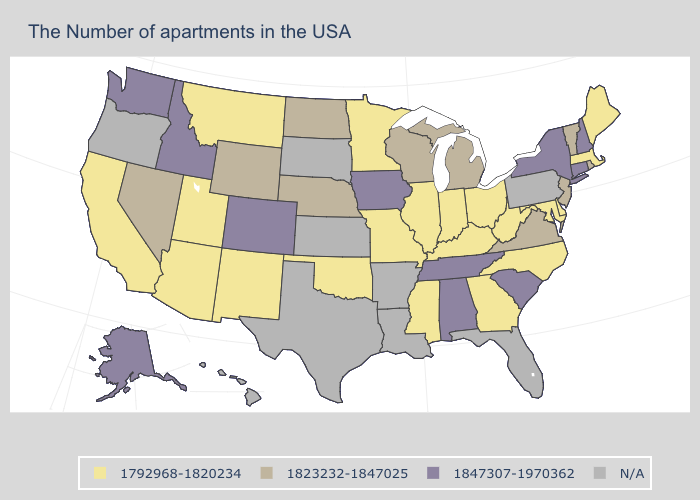What is the lowest value in the West?
Give a very brief answer. 1792968-1820234. Which states have the lowest value in the USA?
Write a very short answer. Maine, Massachusetts, Delaware, Maryland, North Carolina, West Virginia, Ohio, Georgia, Kentucky, Indiana, Illinois, Mississippi, Missouri, Minnesota, Oklahoma, New Mexico, Utah, Montana, Arizona, California. What is the value of Wisconsin?
Quick response, please. 1823232-1847025. Name the states that have a value in the range 1823232-1847025?
Quick response, please. Rhode Island, Vermont, New Jersey, Virginia, Michigan, Wisconsin, Nebraska, North Dakota, Wyoming, Nevada. What is the lowest value in the Northeast?
Answer briefly. 1792968-1820234. What is the value of Alabama?
Short answer required. 1847307-1970362. Among the states that border Nevada , which have the lowest value?
Answer briefly. Utah, Arizona, California. Name the states that have a value in the range 1823232-1847025?
Short answer required. Rhode Island, Vermont, New Jersey, Virginia, Michigan, Wisconsin, Nebraska, North Dakota, Wyoming, Nevada. Which states hav the highest value in the Northeast?
Give a very brief answer. New Hampshire, Connecticut, New York. What is the highest value in states that border Georgia?
Answer briefly. 1847307-1970362. Does the map have missing data?
Keep it brief. Yes. Does the first symbol in the legend represent the smallest category?
Write a very short answer. Yes. Name the states that have a value in the range N/A?
Give a very brief answer. Pennsylvania, Florida, Louisiana, Arkansas, Kansas, Texas, South Dakota, Oregon, Hawaii. Name the states that have a value in the range 1792968-1820234?
Short answer required. Maine, Massachusetts, Delaware, Maryland, North Carolina, West Virginia, Ohio, Georgia, Kentucky, Indiana, Illinois, Mississippi, Missouri, Minnesota, Oklahoma, New Mexico, Utah, Montana, Arizona, California. 